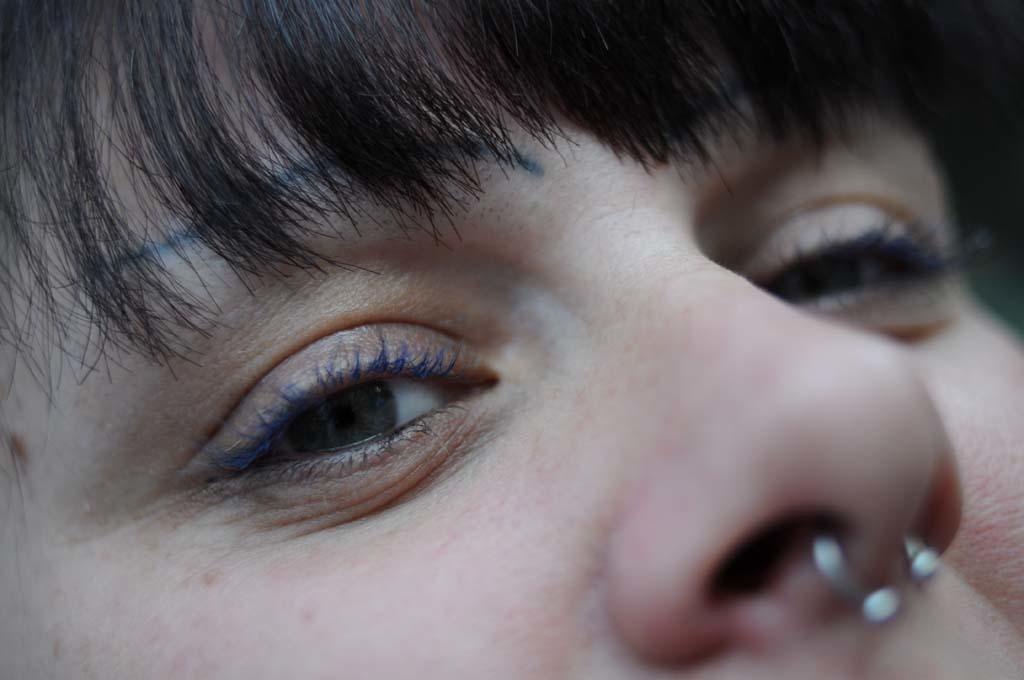Can you describe this image briefly? In this image there is a person wearing a nose pin. Person's forehead is covered with hair. 